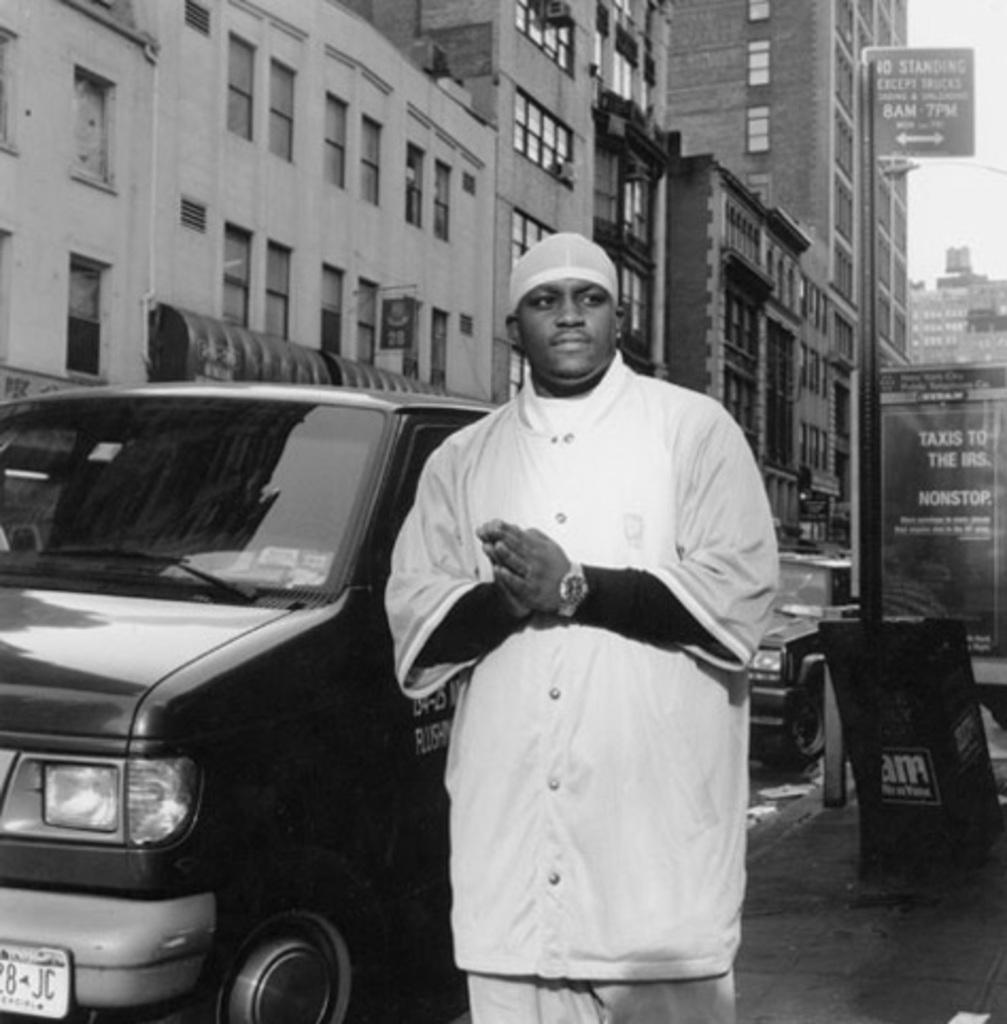<image>
Relay a brief, clear account of the picture shown. black & white photo of a man in black next to a van and a sign that has taxis to the irs on it in the background 